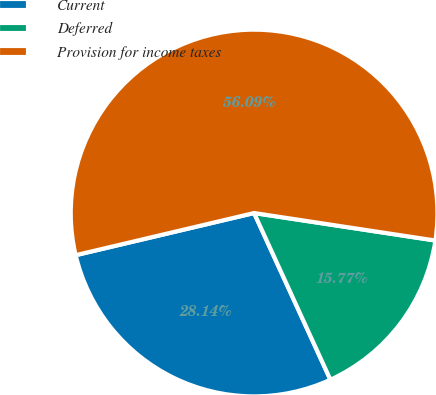Convert chart. <chart><loc_0><loc_0><loc_500><loc_500><pie_chart><fcel>Current<fcel>Deferred<fcel>Provision for income taxes<nl><fcel>28.14%<fcel>15.77%<fcel>56.09%<nl></chart> 